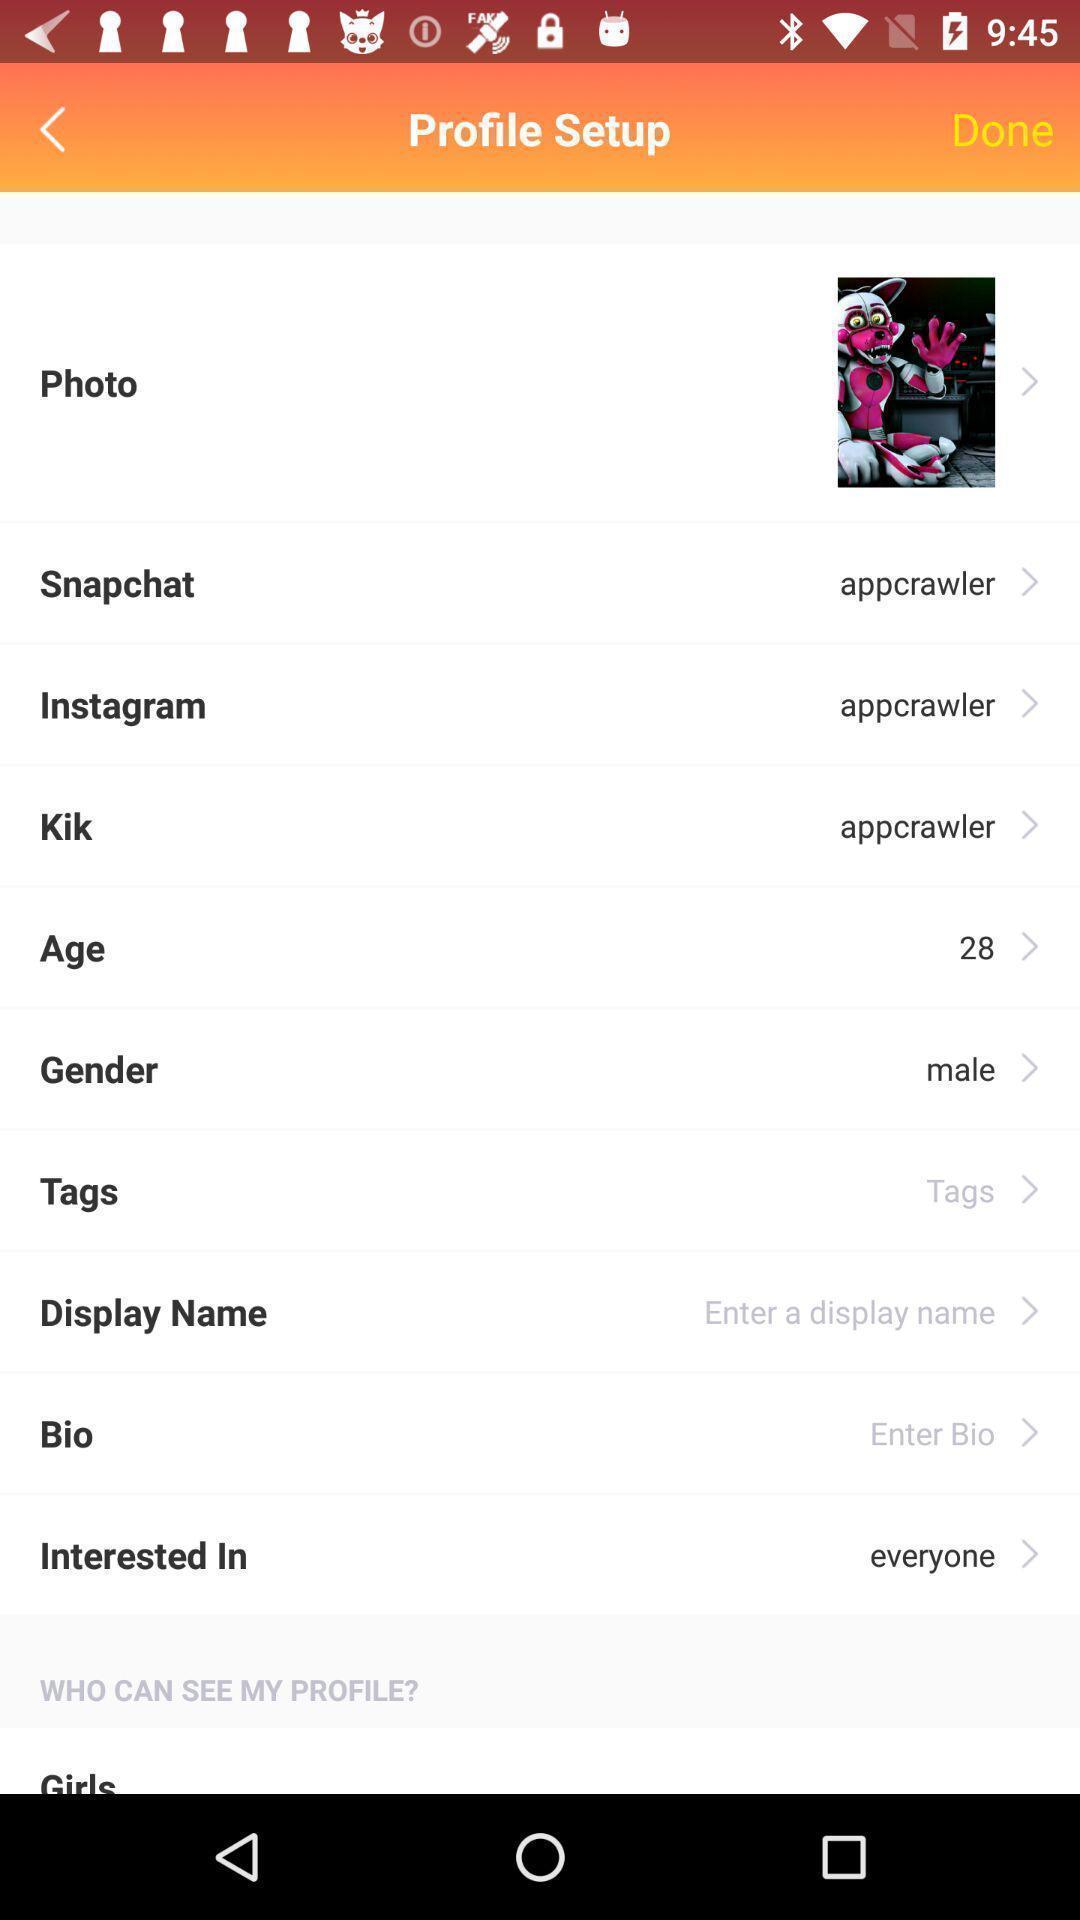What details can you identify in this image? Screen displaying setting of a profile. 